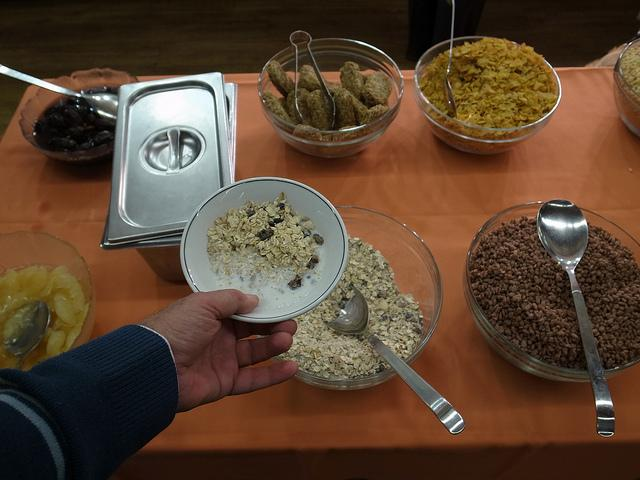What's most likely in the box?

Choices:
A) napkins
B) more food
C) gas
D) water more food 